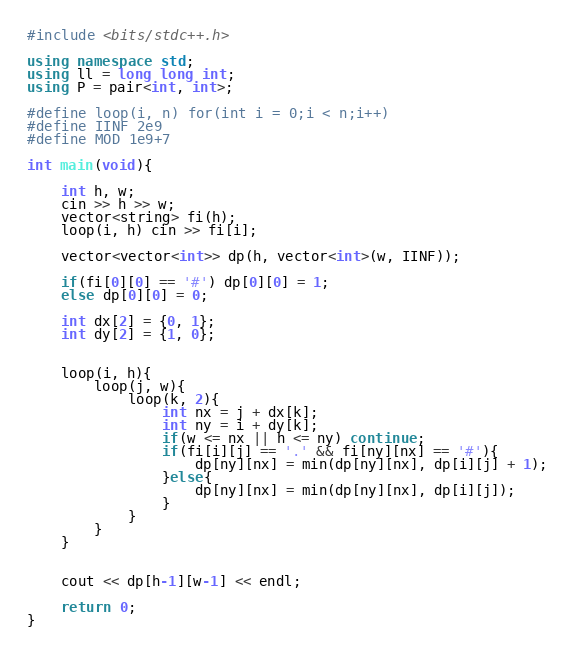<code> <loc_0><loc_0><loc_500><loc_500><_C++_>#include <bits/stdc++.h>

using namespace std;
using ll = long long int;
using P = pair<int, int>;

#define loop(i, n) for(int i = 0;i < n;i++)
#define IINF 2e9
#define MOD 1e9+7

int main(void){

    int h, w;
    cin >> h >> w;
    vector<string> fi(h);
    loop(i, h) cin >> fi[i];

    vector<vector<int>> dp(h, vector<int>(w, IINF));

    if(fi[0][0] == '#') dp[0][0] = 1;
    else dp[0][0] = 0;

    int dx[2] = {0, 1};
    int dy[2] = {1, 0};


    loop(i, h){
        loop(j, w){
            loop(k, 2){
                int nx = j + dx[k];
                int ny = i + dy[k];
                if(w <= nx || h <= ny) continue;
                if(fi[i][j] == '.' && fi[ny][nx] == '#'){
                    dp[ny][nx] = min(dp[ny][nx], dp[i][j] + 1);
                }else{
                    dp[ny][nx] = min(dp[ny][nx], dp[i][j]);
                }
            }
        }
    }


    cout << dp[h-1][w-1] << endl;

    return 0;
}</code> 